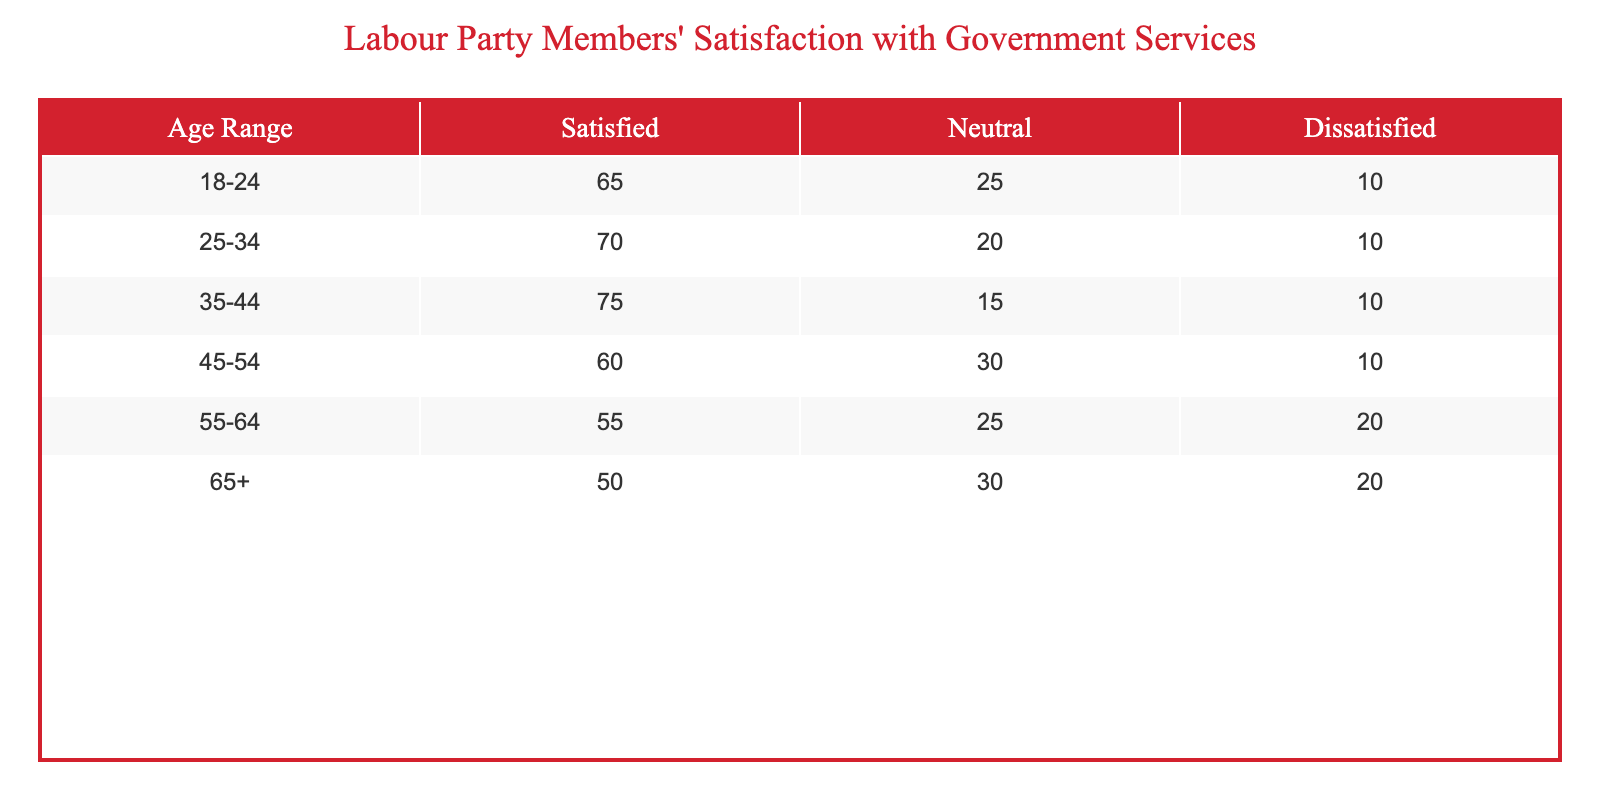What is the satisfaction level of the 25-34 age group? The table shows that for the 25-34 age group, the count of satisfied members is 70.
Answer: 70 Which age group has the highest percentage of dissatisfied members? The 55-64 age group has 20 dissatisfied members, which is the highest compared to the others that have 10 or less.
Answer: 55-64 What is the total number of satisfied members across all age groups? When we sum the satisfied counts: 65 + 70 + 75 + 60 + 55 + 50 = 375.
Answer: 375 Is it true that the 45-54 age group has more satisfied members than the 65+ age group? Yes, the 45-54 age group has 60 satisfied members, while the 65+ group has only 50.
Answer: Yes What is the average number of neutral responses across all age groups? To find the average of neutral responses, we sum them: 25 + 20 + 15 + 30 + 25 + 30 = 145, then divide by the number of age groups (6), which gives 145/6 = 24.17.
Answer: 24.17 Which age group has the lowest satisfaction level, and how many members are satisfied? The 65+ age group has the lowest satisfaction level with 50 satisfied members.
Answer: 65+, 50 How many more members are neutral in the 45-54 age group compared to the 55-64 age group? The 45-54 age group has 30 neutral members, while the 55-64 age group has 25. The difference is 30 - 25 = 5.
Answer: 5 Does the age range 18-24 have more satisfied members than the age range 55-64? Yes, the 18-24 age group has 65 satisfied members compared to the 55-64 age group's 55.
Answer: Yes What is the difference in the number of satisfied and dissatisfied members in the 35-44 age group? The count for satisfied is 75 and for dissatisfied, it is 10. The difference is 75 - 10 = 65.
Answer: 65 